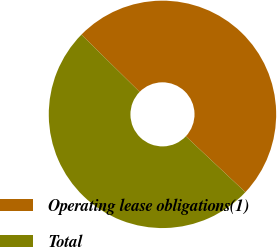<chart> <loc_0><loc_0><loc_500><loc_500><pie_chart><fcel>Operating lease obligations(1)<fcel>Total<nl><fcel>49.63%<fcel>50.37%<nl></chart> 